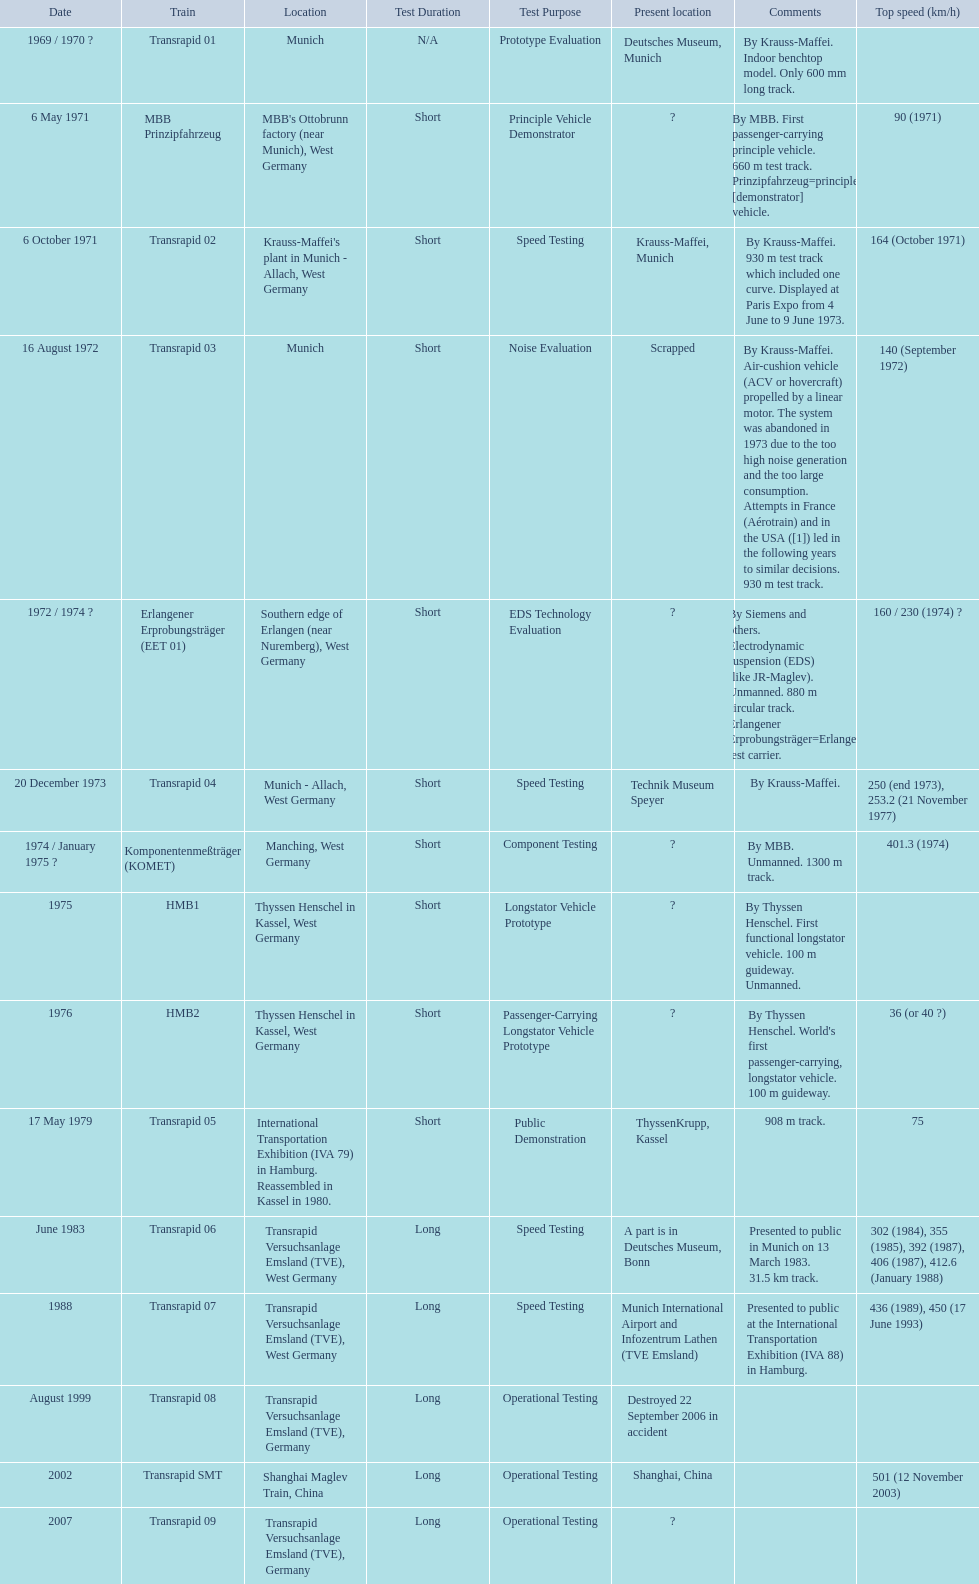Can you give me this table as a dict? {'header': ['Date', 'Train', 'Location', 'Test Duration', 'Test Purpose', 'Present location', 'Comments', 'Top speed (km/h)'], 'rows': [['1969 / 1970\xa0?', 'Transrapid 01', 'Munich', 'N/A', 'Prototype Evaluation', 'Deutsches Museum, Munich', 'By Krauss-Maffei. Indoor benchtop model. Only 600\xa0mm long track.', ''], ['6 May 1971', 'MBB Prinzipfahrzeug', "MBB's Ottobrunn factory (near Munich), West Germany", 'Short', 'Principle Vehicle Demonstrator', '?', 'By MBB. First passenger-carrying principle vehicle. 660 m test track. Prinzipfahrzeug=principle [demonstrator] vehicle.', '90 (1971)'], ['6 October 1971', 'Transrapid 02', "Krauss-Maffei's plant in Munich - Allach, West Germany", 'Short', 'Speed Testing', 'Krauss-Maffei, Munich', 'By Krauss-Maffei. 930 m test track which included one curve. Displayed at Paris Expo from 4 June to 9 June 1973.', '164 (October 1971)'], ['16 August 1972', 'Transrapid 03', 'Munich', 'Short', 'Noise Evaluation', 'Scrapped', 'By Krauss-Maffei. Air-cushion vehicle (ACV or hovercraft) propelled by a linear motor. The system was abandoned in 1973 due to the too high noise generation and the too large consumption. Attempts in France (Aérotrain) and in the USA ([1]) led in the following years to similar decisions. 930 m test track.', '140 (September 1972)'], ['1972 / 1974\xa0?', 'Erlangener Erprobungsträger (EET 01)', 'Southern edge of Erlangen (near Nuremberg), West Germany', 'Short', 'EDS Technology Evaluation', '?', 'By Siemens and others. Electrodynamic suspension (EDS) (like JR-Maglev). Unmanned. 880 m circular track. Erlangener Erprobungsträger=Erlangen test carrier.', '160 / 230 (1974)\xa0?'], ['20 December 1973', 'Transrapid 04', 'Munich - Allach, West Germany', 'Short', 'Speed Testing', 'Technik Museum Speyer', 'By Krauss-Maffei.', '250 (end 1973), 253.2 (21 November 1977)'], ['1974 / January 1975\xa0?', 'Komponentenmeßträger (KOMET)', 'Manching, West Germany', 'Short', 'Component Testing', '?', 'By MBB. Unmanned. 1300 m track.', '401.3 (1974)'], ['1975', 'HMB1', 'Thyssen Henschel in Kassel, West Germany', 'Short', 'Longstator Vehicle Prototype', '?', 'By Thyssen Henschel. First functional longstator vehicle. 100 m guideway. Unmanned.', ''], ['1976', 'HMB2', 'Thyssen Henschel in Kassel, West Germany', 'Short', 'Passenger-Carrying Longstator Vehicle Prototype', '?', "By Thyssen Henschel. World's first passenger-carrying, longstator vehicle. 100 m guideway.", '36 (or 40\xa0?)'], ['17 May 1979', 'Transrapid 05', 'International Transportation Exhibition (IVA 79) in Hamburg. Reassembled in Kassel in 1980.', 'Short', 'Public Demonstration', 'ThyssenKrupp, Kassel', '908 m track.', '75'], ['June 1983', 'Transrapid 06', 'Transrapid Versuchsanlage Emsland (TVE), West Germany', 'Long', 'Speed Testing', 'A part is in Deutsches Museum, Bonn', 'Presented to public in Munich on 13 March 1983. 31.5\xa0km track.', '302 (1984), 355 (1985), 392 (1987), 406 (1987), 412.6 (January 1988)'], ['1988', 'Transrapid 07', 'Transrapid Versuchsanlage Emsland (TVE), West Germany', 'Long', 'Speed Testing', 'Munich International Airport and Infozentrum Lathen (TVE Emsland)', 'Presented to public at the International Transportation Exhibition (IVA 88) in Hamburg.', '436 (1989), 450 (17 June 1993)'], ['August 1999', 'Transrapid 08', 'Transrapid Versuchsanlage Emsland (TVE), Germany', 'Long', 'Operational Testing', 'Destroyed 22 September 2006 in accident', '', ''], ['2002', 'Transrapid SMT', 'Shanghai Maglev Train, China', 'Long', 'Operational Testing', 'Shanghai, China', '', '501 (12 November 2003)'], ['2007', 'Transrapid 09', 'Transrapid Versuchsanlage Emsland (TVE), Germany', 'Long', 'Operational Testing', '?', '', '']]} Which trains had a top speed listed? MBB Prinzipfahrzeug, Transrapid 02, Transrapid 03, Erlangener Erprobungsträger (EET 01), Transrapid 04, Komponentenmeßträger (KOMET), HMB2, Transrapid 05, Transrapid 06, Transrapid 07, Transrapid SMT. Which ones list munich as a location? MBB Prinzipfahrzeug, Transrapid 02, Transrapid 03. Of these which ones present location is known? Transrapid 02, Transrapid 03. Which of those is no longer in operation? Transrapid 03. 